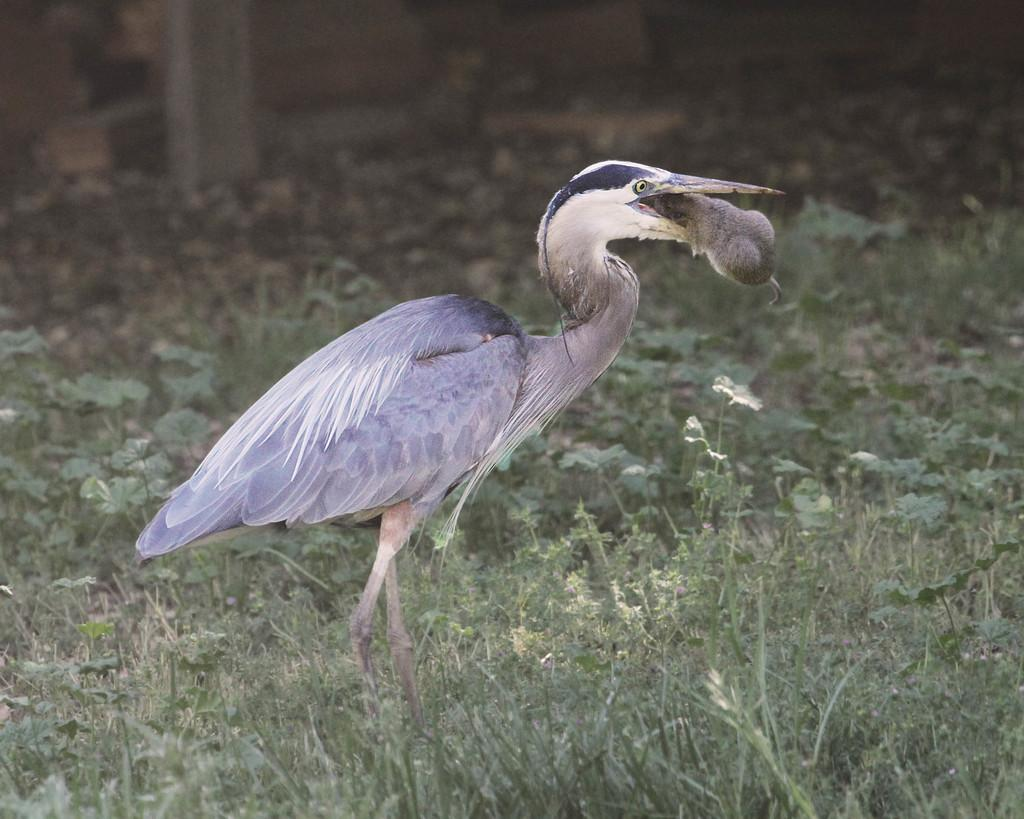What type of animal can be seen in the image? There is a bird in the image. What is the bird doing in the image? The bird is holding an animal in its mouth. What can be seen in the background of the image? There are plants and objects in the background of the image. How would you describe the background of the image? The background is blurry. What type of advertisement can be seen in the image? There is no advertisement present in the image; it features a bird holding an animal in its mouth with a blurry background. What station might this image be associated with? The image is not associated with any specific station, as it does not contain any information or context related to a station. 